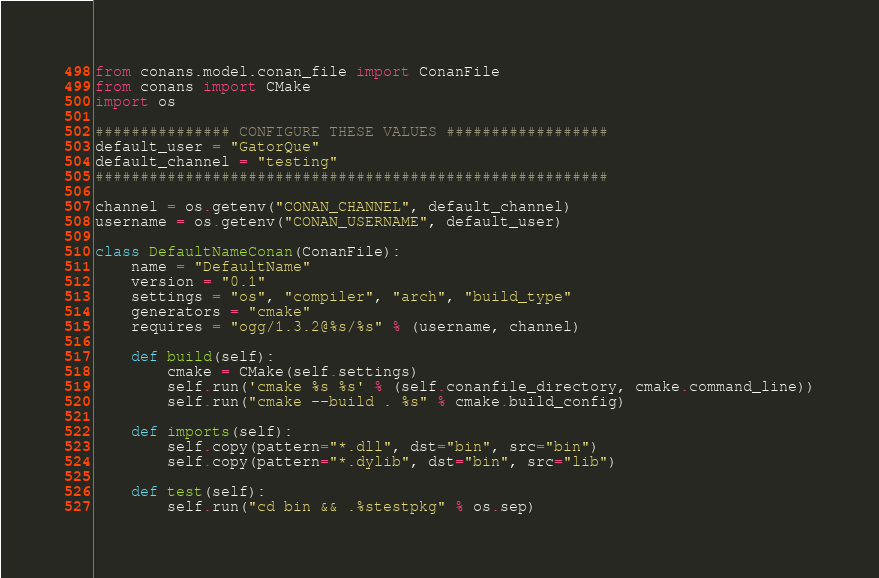Convert code to text. <code><loc_0><loc_0><loc_500><loc_500><_Python_>from conans.model.conan_file import ConanFile
from conans import CMake
import os

############### CONFIGURE THESE VALUES ##################
default_user = "GatorQue"
default_channel = "testing"
#########################################################

channel = os.getenv("CONAN_CHANNEL", default_channel)
username = os.getenv("CONAN_USERNAME", default_user)

class DefaultNameConan(ConanFile):
    name = "DefaultName"
    version = "0.1"
    settings = "os", "compiler", "arch", "build_type"
    generators = "cmake"
    requires = "ogg/1.3.2@%s/%s" % (username, channel)

    def build(self):
        cmake = CMake(self.settings)
        self.run('cmake %s %s' % (self.conanfile_directory, cmake.command_line))
        self.run("cmake --build . %s" % cmake.build_config)

    def imports(self):
        self.copy(pattern="*.dll", dst="bin", src="bin")
        self.copy(pattern="*.dylib", dst="bin", src="lib")
        
    def test(self):
        self.run("cd bin && .%stestpkg" % os.sep)
</code> 